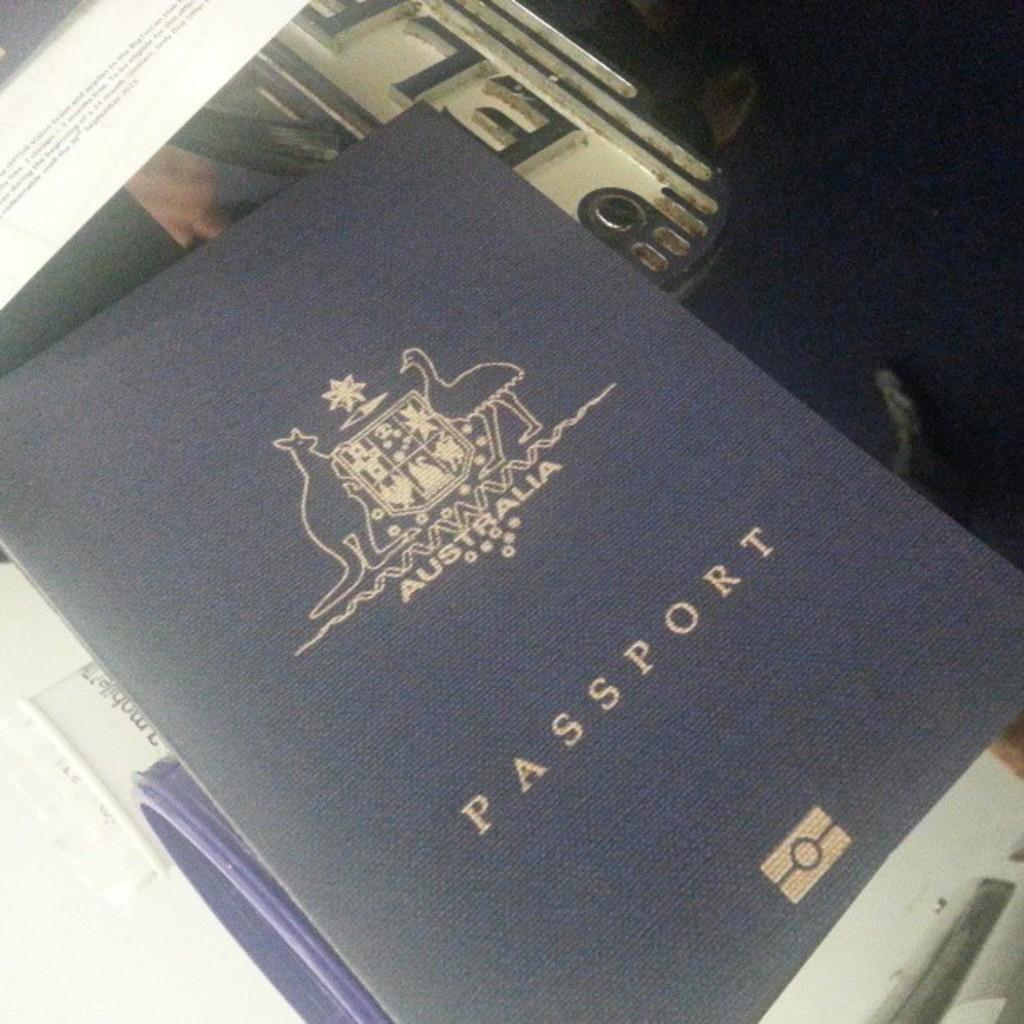<image>
Relay a brief, clear account of the picture shown. the word passport is on the blue item 